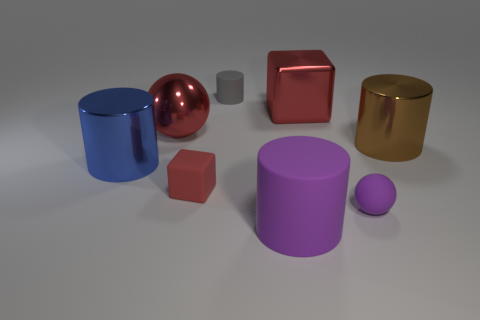Subtract all tiny gray matte cylinders. How many cylinders are left? 3 Subtract all brown cylinders. How many cylinders are left? 3 Add 1 green matte objects. How many objects exist? 9 Subtract all red cylinders. Subtract all brown balls. How many cylinders are left? 4 Subtract all balls. How many objects are left? 6 Subtract 1 blue cylinders. How many objects are left? 7 Subtract all large green matte balls. Subtract all big brown shiny cylinders. How many objects are left? 7 Add 6 big brown shiny cylinders. How many big brown shiny cylinders are left? 7 Add 2 gray cylinders. How many gray cylinders exist? 3 